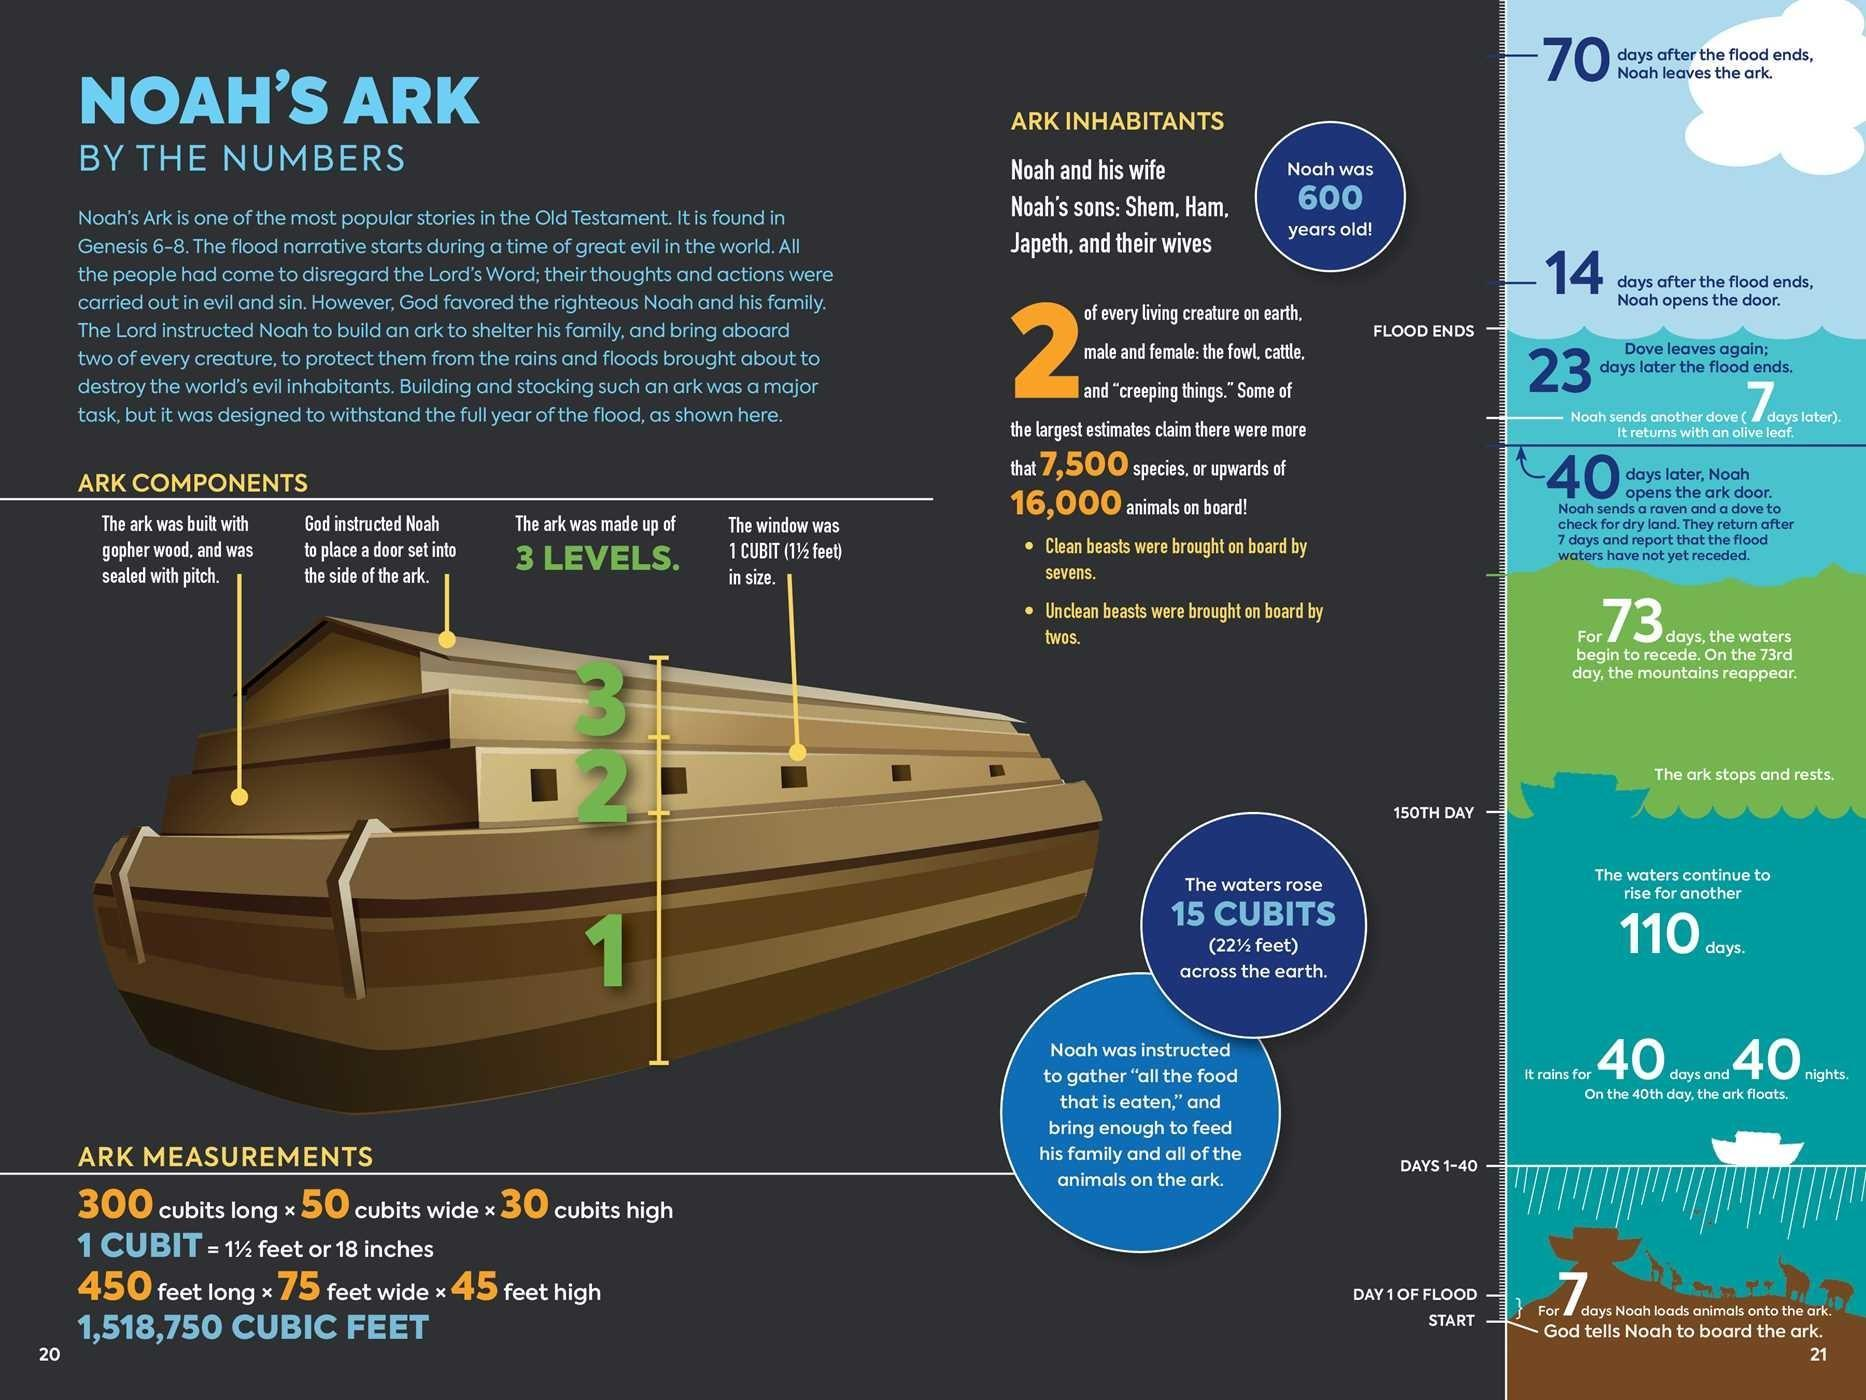What is the material used to build an ark?
Answer the question with a short phrase. gopher wood 